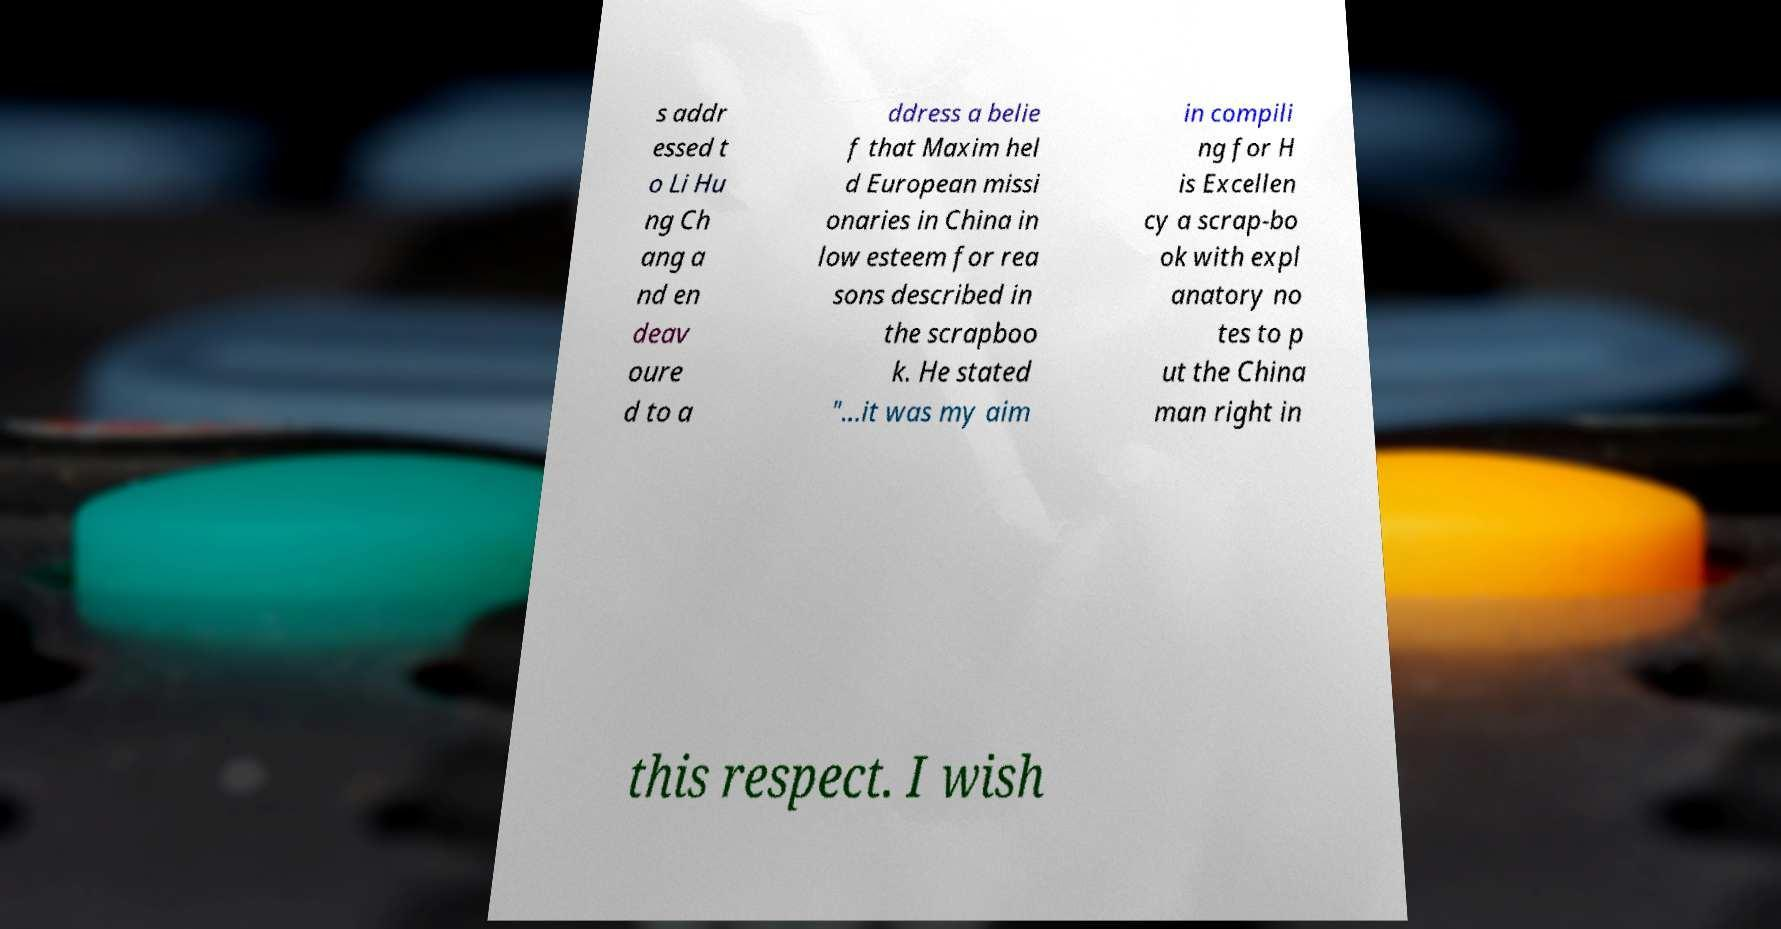Can you read and provide the text displayed in the image?This photo seems to have some interesting text. Can you extract and type it out for me? s addr essed t o Li Hu ng Ch ang a nd en deav oure d to a ddress a belie f that Maxim hel d European missi onaries in China in low esteem for rea sons described in the scrapboo k. He stated "...it was my aim in compili ng for H is Excellen cy a scrap-bo ok with expl anatory no tes to p ut the China man right in this respect. I wish 